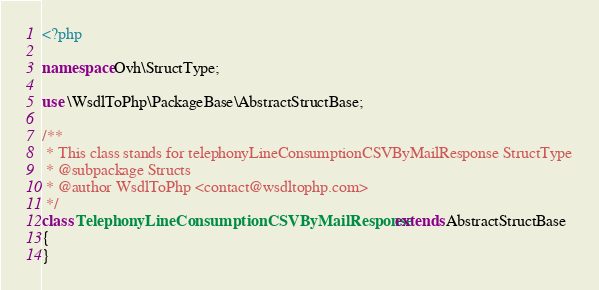Convert code to text. <code><loc_0><loc_0><loc_500><loc_500><_PHP_><?php

namespace Ovh\StructType;

use \WsdlToPhp\PackageBase\AbstractStructBase;

/**
 * This class stands for telephonyLineConsumptionCSVByMailResponse StructType
 * @subpackage Structs
 * @author WsdlToPhp <contact@wsdltophp.com>
 */
class TelephonyLineConsumptionCSVByMailResponse extends AbstractStructBase
{
}
</code> 